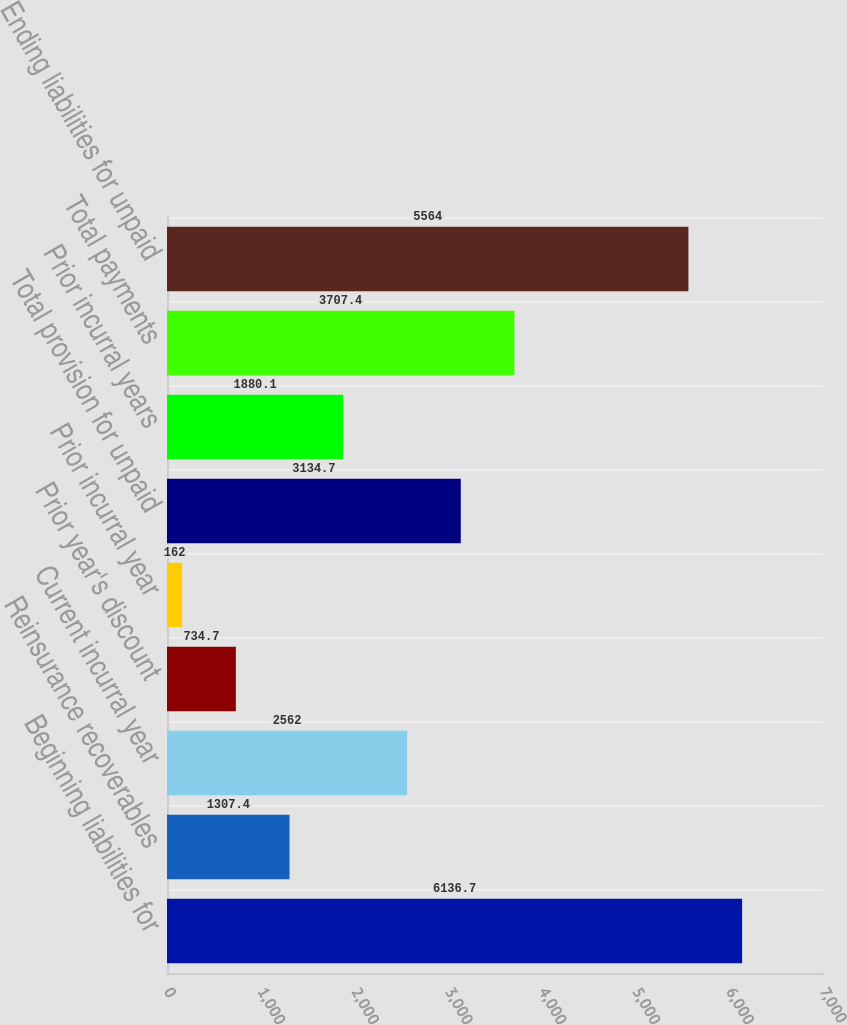<chart> <loc_0><loc_0><loc_500><loc_500><bar_chart><fcel>Beginning liabilities for<fcel>Reinsurance recoverables<fcel>Current incurral year<fcel>Prior year's discount<fcel>Prior incurral year<fcel>Total provision for unpaid<fcel>Prior incurral years<fcel>Total payments<fcel>Ending liabilities for unpaid<nl><fcel>6136.7<fcel>1307.4<fcel>2562<fcel>734.7<fcel>162<fcel>3134.7<fcel>1880.1<fcel>3707.4<fcel>5564<nl></chart> 